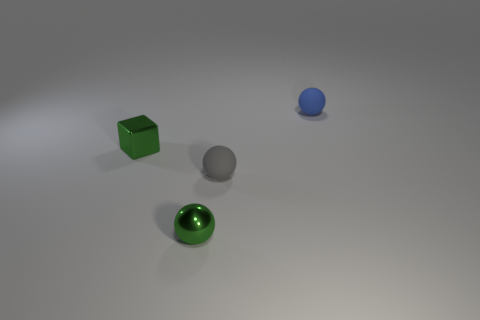Add 3 small gray objects. How many objects exist? 7 Subtract all balls. How many objects are left? 1 Subtract all small green metallic blocks. Subtract all green balls. How many objects are left? 2 Add 2 small blue matte spheres. How many small blue matte spheres are left? 3 Add 4 gray matte things. How many gray matte things exist? 5 Subtract 0 blue cubes. How many objects are left? 4 